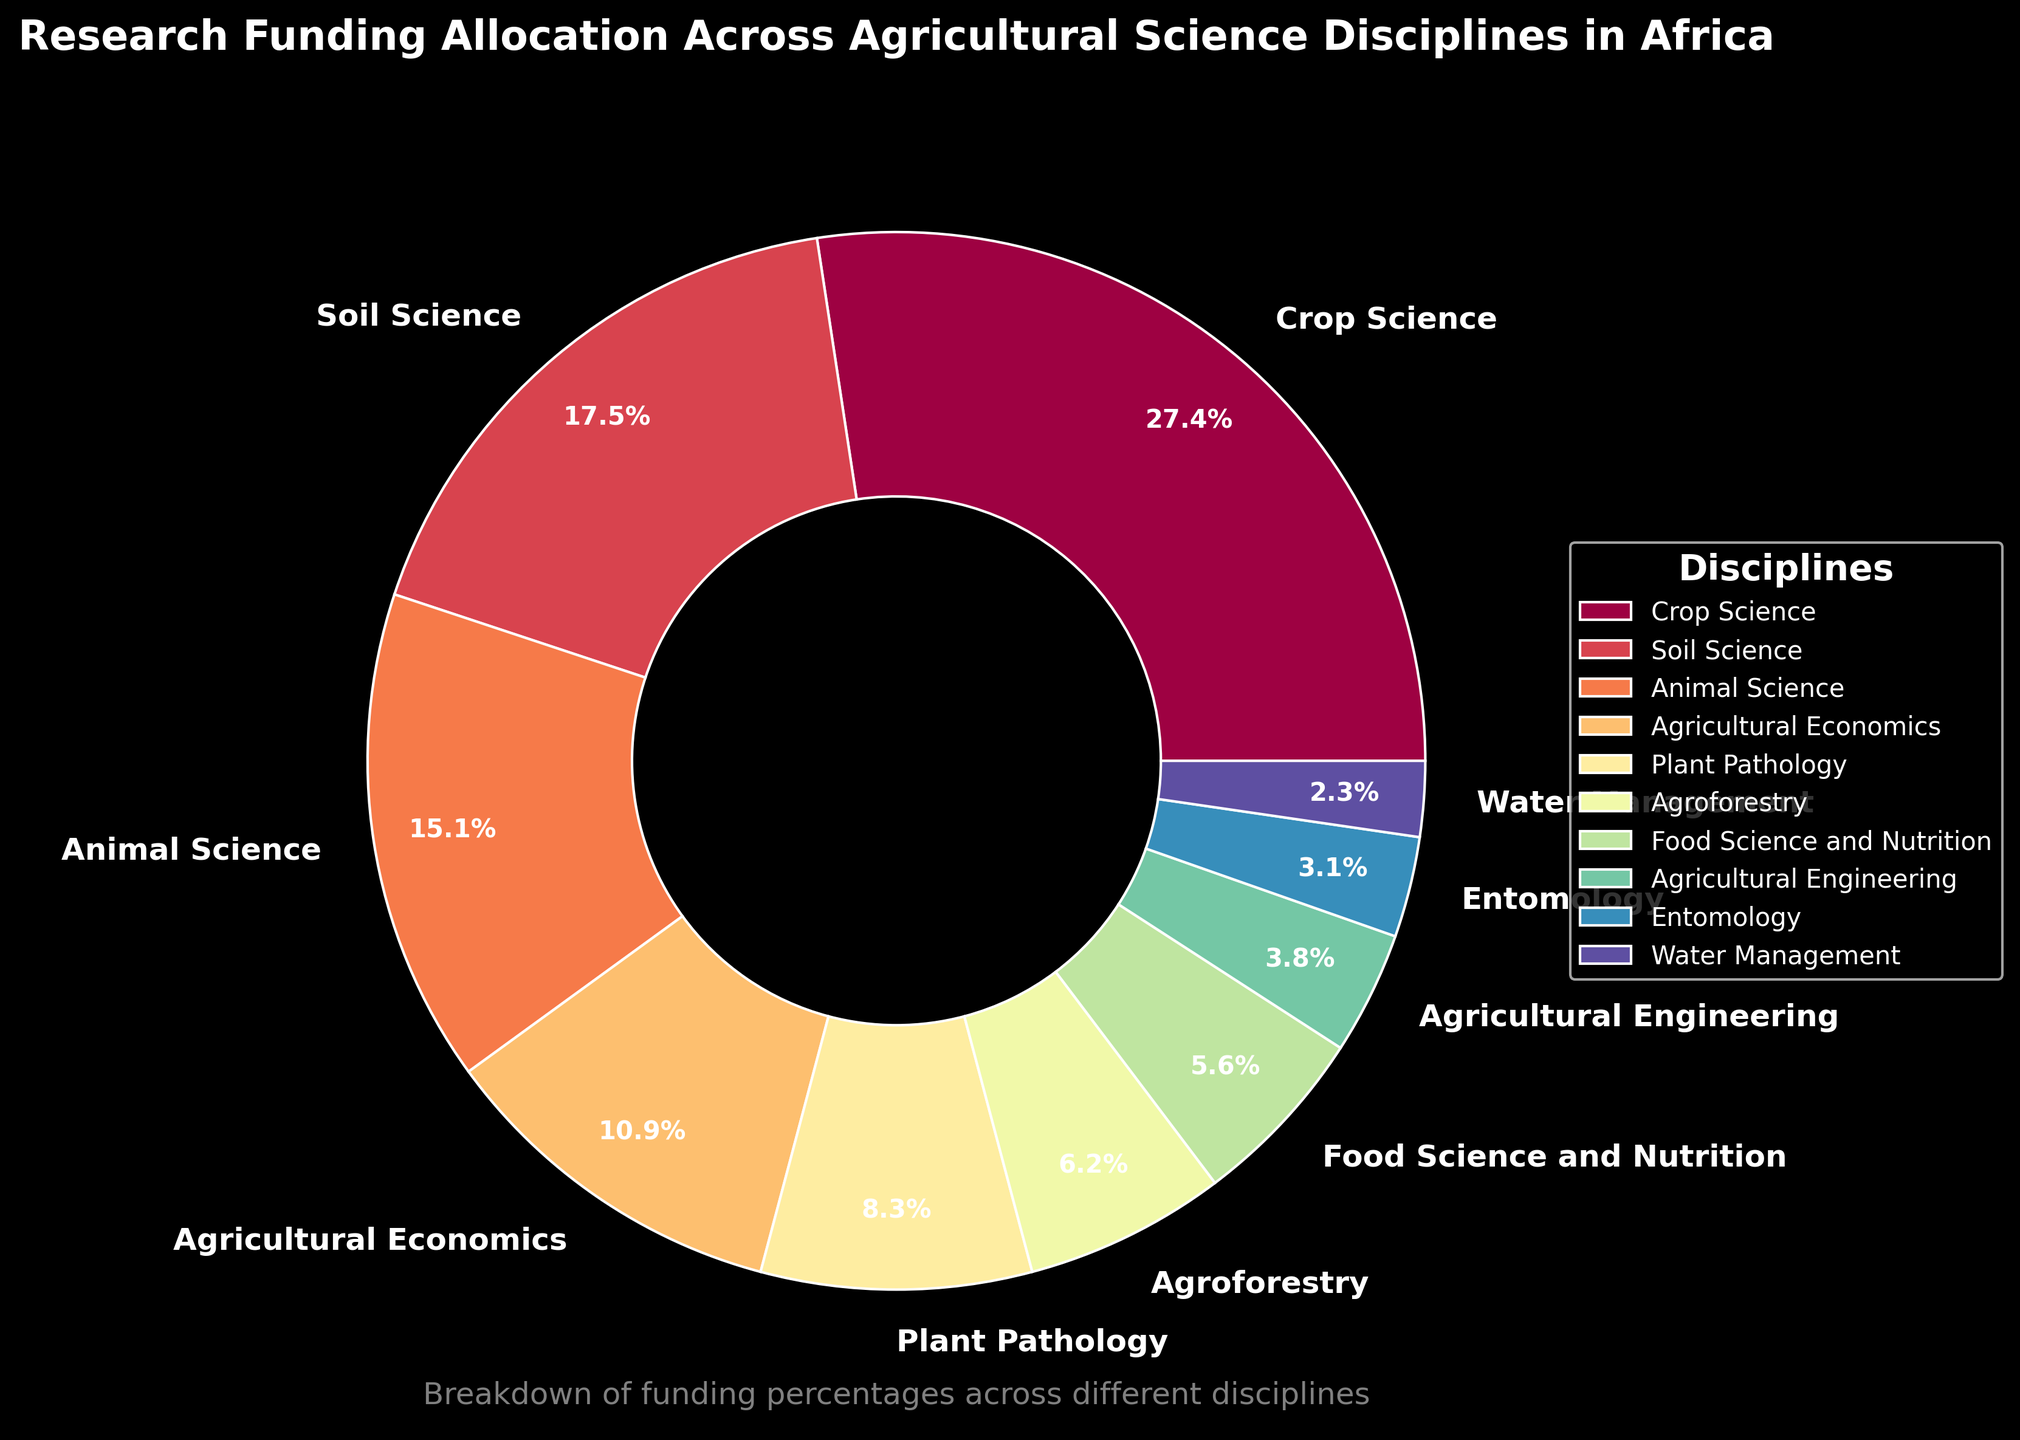Which discipline receives the largest portion of research funding? The largest portion of research funding is indicated by the discipline with the highest percentage value on the pie chart.
Answer: Crop Science How much more funding does Crop Science receive compared to Animal Science? To determine the difference in funding percentages between Crop Science and Animal Science, subtract Animal Science's percentage from Crop Science's percentage. 28.5% (Crop Science) - 15.7% (Animal Science) = 12.8%.
Answer: 12.8% Which disciplines receive less than 5% of the total funding? Disciplines receiving less than 5% of the funding are identified by their percentage values on the pie chart being below 5%. Entomology (3.2%) and Water Management (2.4%) both receive less than 5%.
Answer: Entomology and Water Management What is the combined funding percentage for Agroforestry and Plant Pathology? To combine the funding percentages for Agroforestry and Plant Pathology, sum their individual percentages. 6.4% (Agroforestry) + 8.6% (Plant Pathology) = 15%.
Answer: 15% How does the funding for Soil Science compare to Agricultural Economics? Compare the funding percentages by examining the values on the pie chart. Soil Science has 18.2% while Agricultural Economics has 11.3%. Thus, Soil Science receives more funding.
Answer: Soil Science receives more funding What percentage of total funding is allocated to disciplines related to biology (Crop Science, Animal Science, Plant Pathology, Entomology)? Add up the funding percentages for the biological-related disciplines. Crop Science (28.5%) + Animal Science (15.7%) + Plant Pathology (8.6%) + Entomology (3.2%) = 56%.
Answer: 56% How many disciplines receive more than 10% of the total funding? Count the disciplines on the pie chart with funding percentages above 10%. Crop Science (28.5%), Soil Science (18.2%), and Animal Science (15.7%) are three disciplines that meet this criterion.
Answer: Three disciplines What is the difference in funding between the least funded and the most funded disciplines? The least funded discipline is Water Management at 2.4%, and the most funded discipline is Crop Science at 28.5%. Subtract the smallest percentage from the largest. 28.5% - 2.4% = 26.1%.
Answer: 26.1% Which discipline is visually represented with the smallest wedge in the pie chart? The smallest wedge visually represents the discipline with the lowest percentage. Water Management has the smallest percentage at 2.4%.
Answer: Water Management How does the funding for Food Science and Nutrition compare to Agricultural Engineering? Compare the percentages on the pie chart. Food Science and Nutrition has 5.8%, while Agricultural Engineering has 3.9%. Thus, Food Science and Nutrition receives more funding.
Answer: Food Science and Nutrition receives more funding 